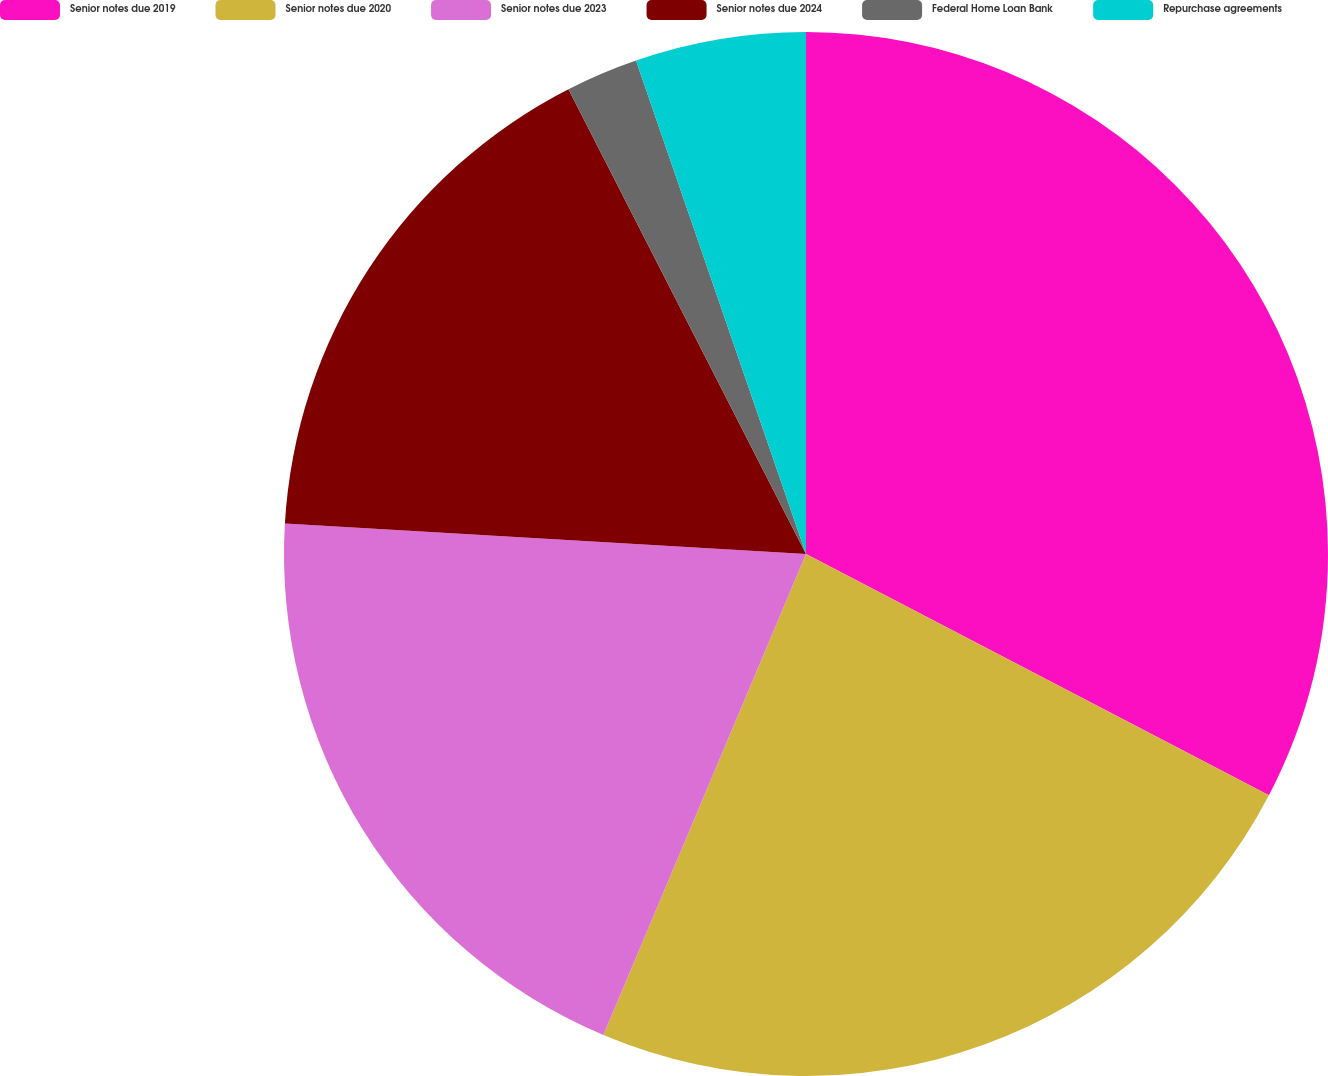Convert chart to OTSL. <chart><loc_0><loc_0><loc_500><loc_500><pie_chart><fcel>Senior notes due 2019<fcel>Senior notes due 2020<fcel>Senior notes due 2023<fcel>Senior notes due 2024<fcel>Federal Home Loan Bank<fcel>Repurchase agreements<nl><fcel>32.65%<fcel>23.7%<fcel>19.59%<fcel>16.55%<fcel>2.24%<fcel>5.28%<nl></chart> 